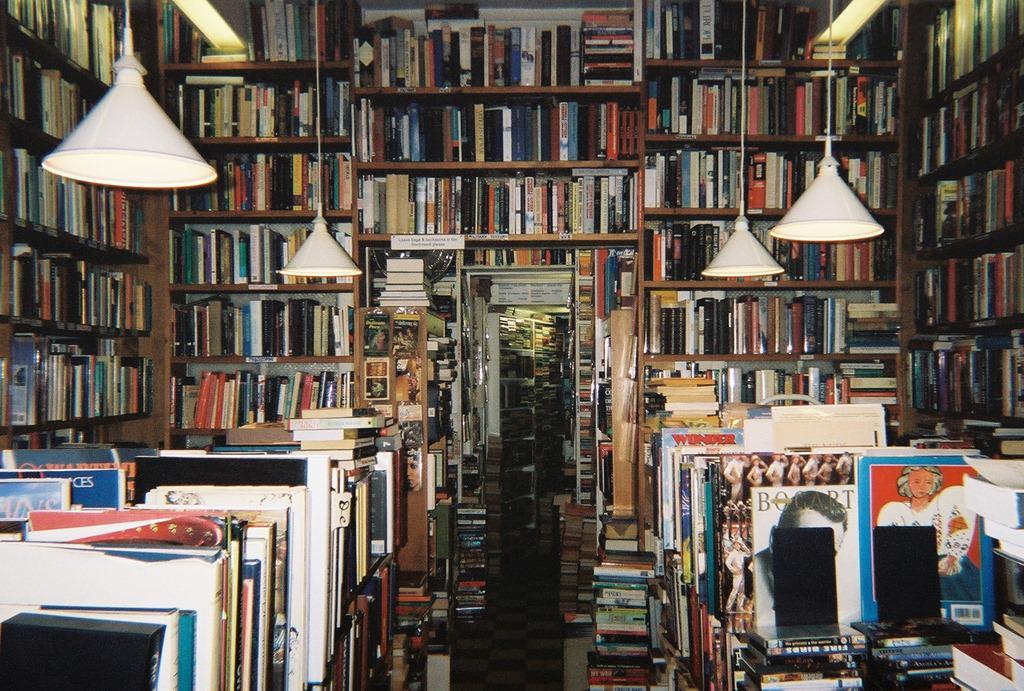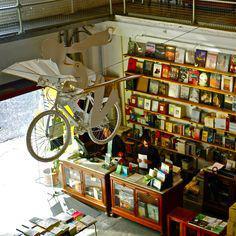The first image is the image on the left, the second image is the image on the right. Assess this claim about the two images: "There are two people in dark shirts behind the counter of a bookstore,". Correct or not? Answer yes or no. Yes. The first image is the image on the left, the second image is the image on the right. For the images displayed, is the sentence "The right image includes a person standing behind a counter that has three white squares in a row on it, and the wall near the counter is filled almost to the ceiling with books." factually correct? Answer yes or no. Yes. 